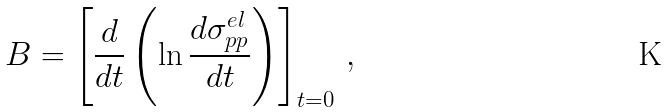<formula> <loc_0><loc_0><loc_500><loc_500>B = \left [ { \frac { d } { d t } } \left ( \ln { \frac { d \sigma _ { p p } ^ { e l } } { d t } } \right ) \right ] _ { t = 0 } \, ,</formula> 